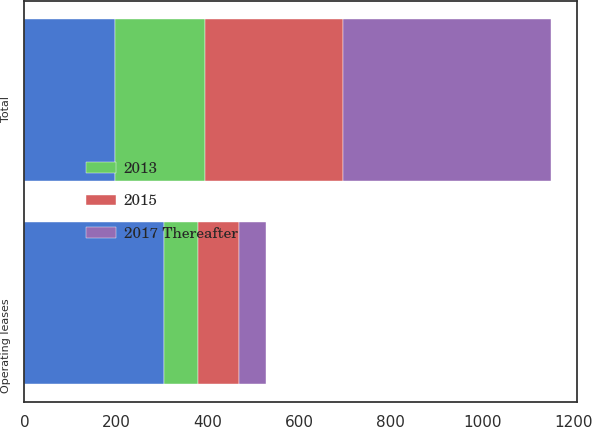<chart> <loc_0><loc_0><loc_500><loc_500><stacked_bar_chart><ecel><fcel>Operating leases<fcel>Total<nl><fcel>nan<fcel>304.5<fcel>197.3<nl><fcel>2015<fcel>87.7<fcel>302<nl><fcel>2013<fcel>75.5<fcel>197.3<nl><fcel>2017 Thereafter<fcel>59.3<fcel>452.8<nl></chart> 